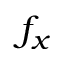Convert formula to latex. <formula><loc_0><loc_0><loc_500><loc_500>f _ { x }</formula> 